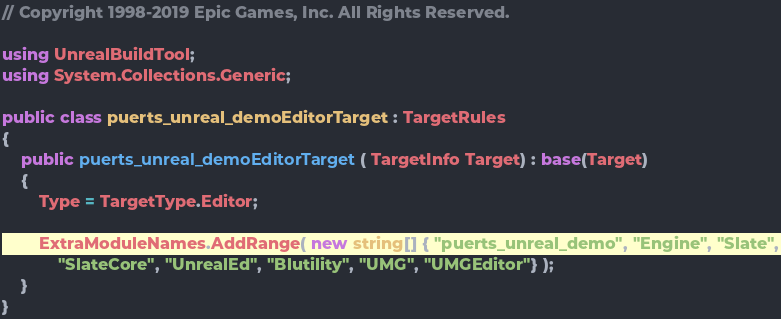<code> <loc_0><loc_0><loc_500><loc_500><_C#_>// Copyright 1998-2019 Epic Games, Inc. All Rights Reserved.

using UnrealBuildTool;
using System.Collections.Generic;

public class puerts_unreal_demoEditorTarget : TargetRules
{
	public puerts_unreal_demoEditorTarget( TargetInfo Target) : base(Target)
	{
		Type = TargetType.Editor;

		ExtraModuleNames.AddRange( new string[] { "puerts_unreal_demo", "Engine", "Slate",
            "SlateCore", "UnrealEd", "Blutility", "UMG", "UMGEditor"} );
    }
}
</code> 